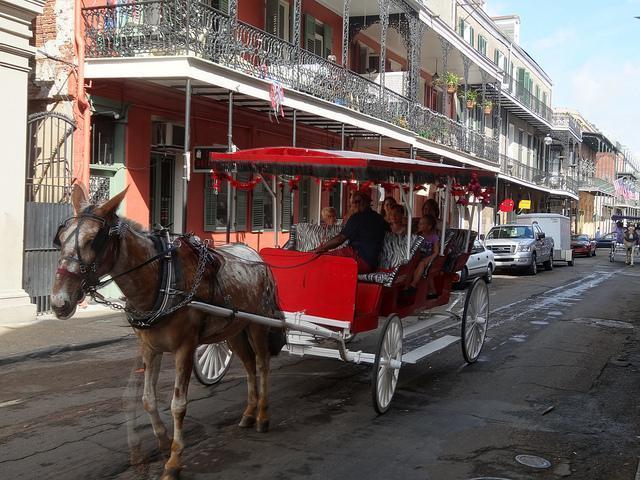How many teddy bears are in the image?
Give a very brief answer. 0. 